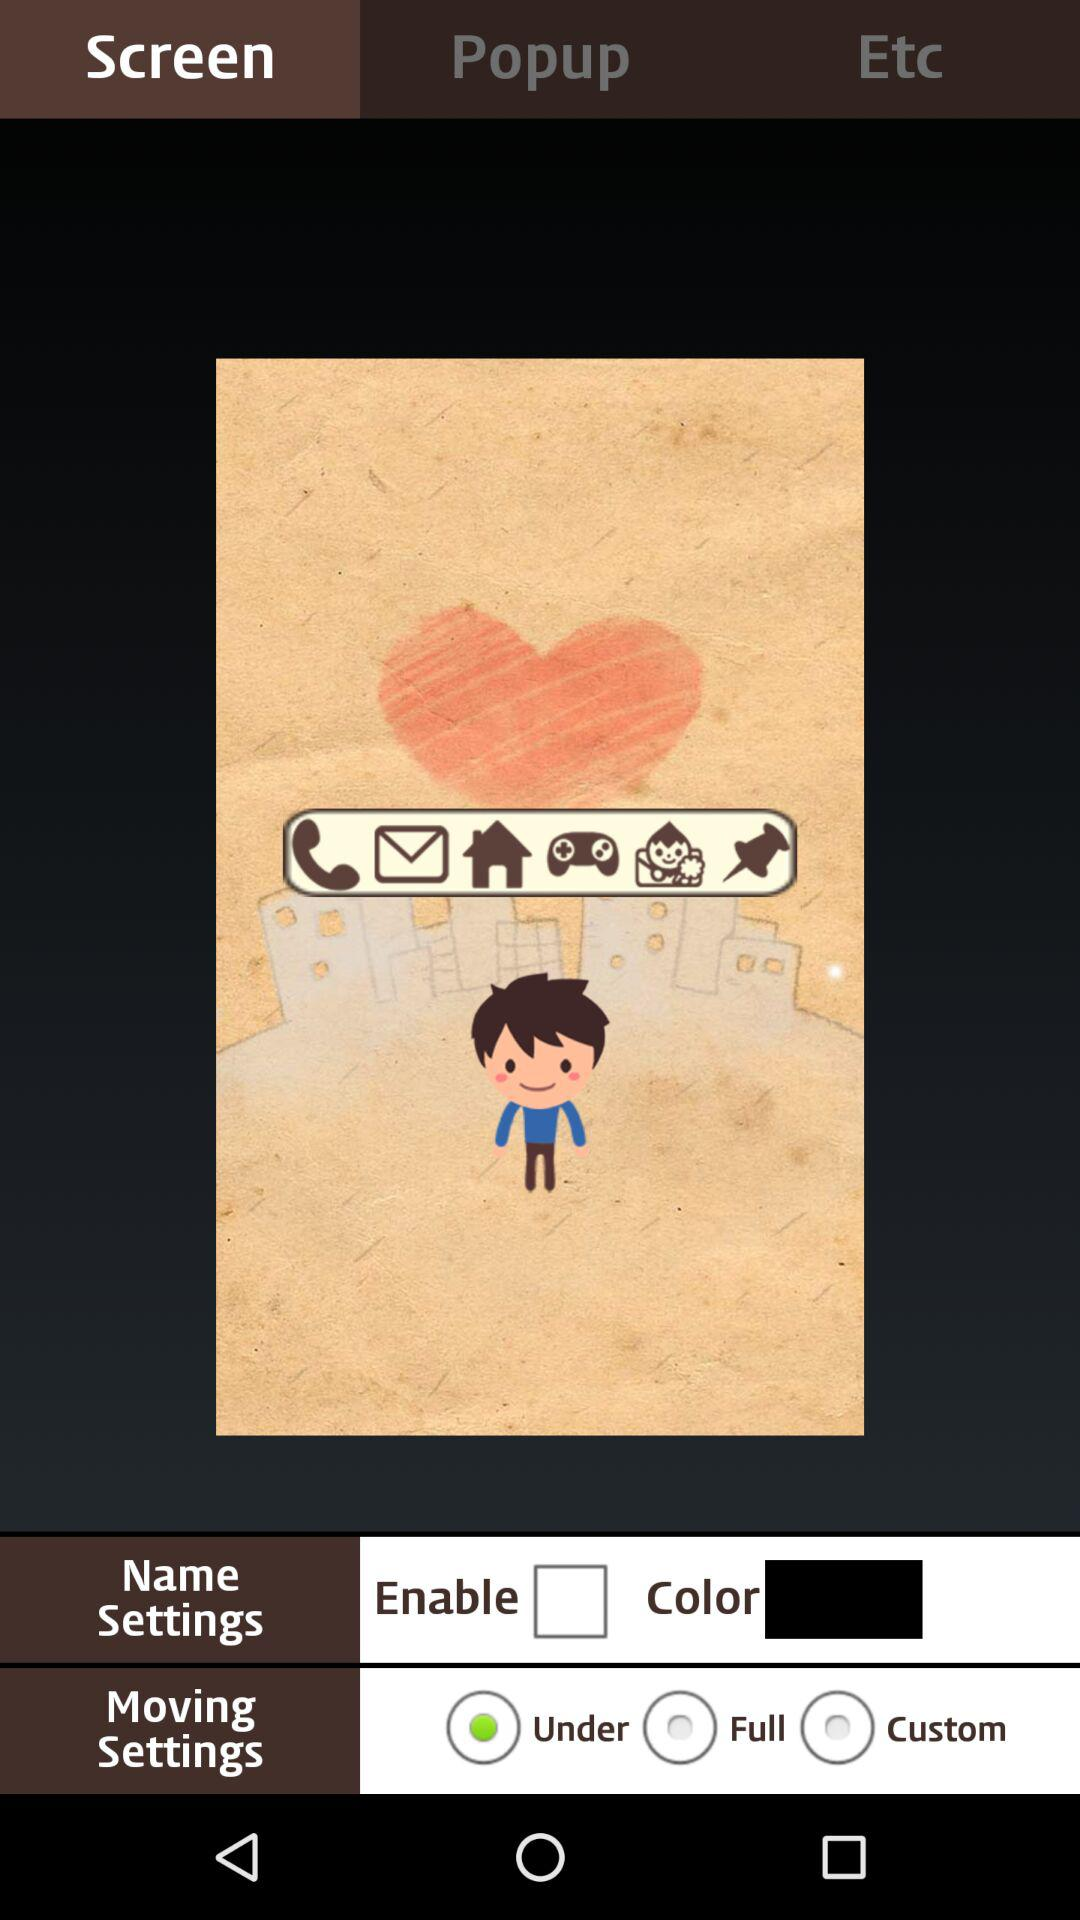Which tab has been selected? The selected tab is "Screen". 